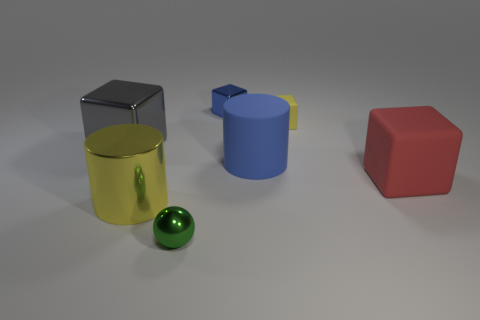There is a large thing that is the same color as the tiny rubber cube; what material is it?
Offer a very short reply. Metal. What is the shape of the tiny yellow object that is to the left of the large red rubber thing?
Provide a succinct answer. Cube. There is a yellow object that is the same size as the green object; what is its material?
Provide a succinct answer. Rubber. What number of things are either rubber blocks behind the gray cube or yellow things on the right side of the small blue thing?
Make the answer very short. 1. The blue object that is made of the same material as the yellow cylinder is what size?
Ensure brevity in your answer.  Small. What number of rubber things are either gray objects or big green cylinders?
Make the answer very short. 0. The blue rubber thing is what size?
Your answer should be compact. Large. Do the blue matte cylinder and the sphere have the same size?
Make the answer very short. No. There is a yellow object that is left of the tiny matte block; what material is it?
Make the answer very short. Metal. What material is the small blue thing that is the same shape as the small yellow matte thing?
Your answer should be compact. Metal. 